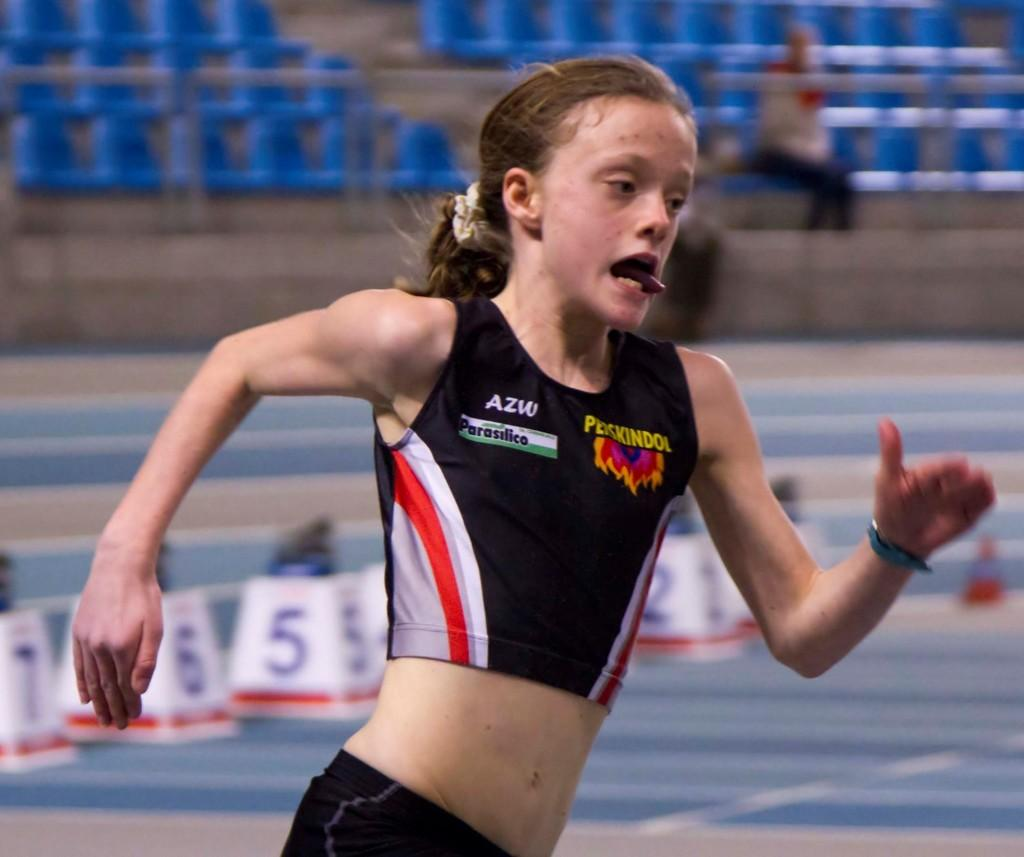<image>
Summarize the visual content of the image. A girl with AZW on her shirt is running on a track. 